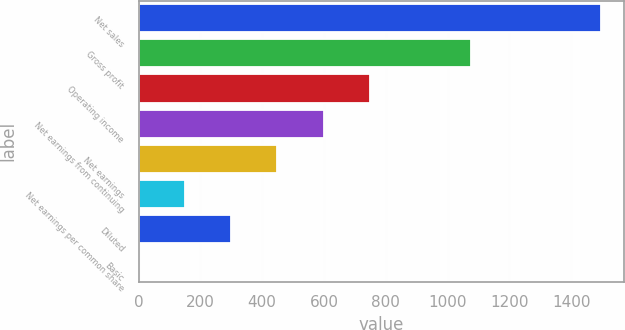Convert chart. <chart><loc_0><loc_0><loc_500><loc_500><bar_chart><fcel>Net sales<fcel>Gross profit<fcel>Operating income<fcel>Net earnings from continuing<fcel>Net earnings<fcel>Net earnings per common share<fcel>Diluted<fcel>Basic<nl><fcel>1497.1<fcel>1077.6<fcel>748.66<fcel>598.98<fcel>449.3<fcel>149.94<fcel>299.62<fcel>0.26<nl></chart> 